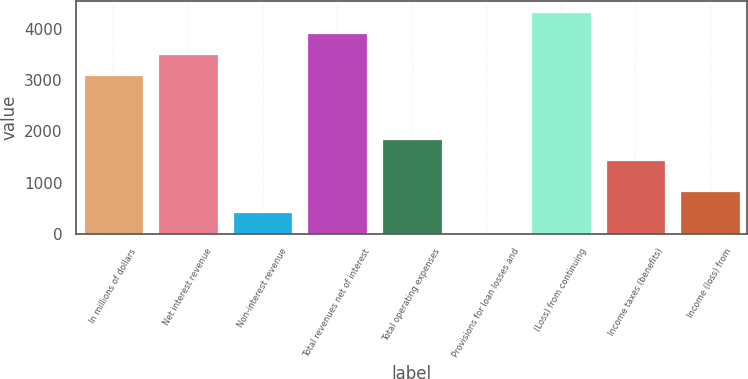Convert chart. <chart><loc_0><loc_0><loc_500><loc_500><bar_chart><fcel>In millions of dollars<fcel>Net interest revenue<fcel>Non-interest revenue<fcel>Total revenues net of interest<fcel>Total operating expenses<fcel>Provisions for loan losses and<fcel>(Loss) from continuing<fcel>Income taxes (benefits)<fcel>Income (loss) from<nl><fcel>3092.8<fcel>3504.5<fcel>414.7<fcel>3916.2<fcel>1857.7<fcel>3<fcel>4327.9<fcel>1446<fcel>826.4<nl></chart> 